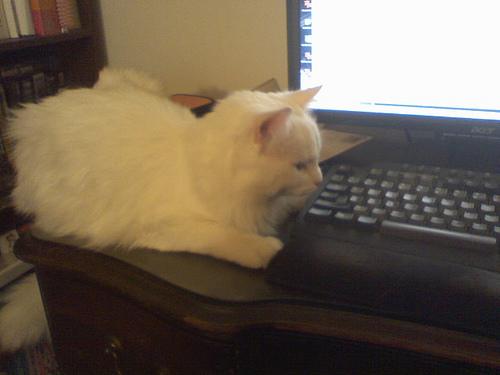What is the cat looking at?
Answer briefly. Keyboard. What color is this cat's fur?
Write a very short answer. White. Is the monitor on?
Give a very brief answer. Yes. 